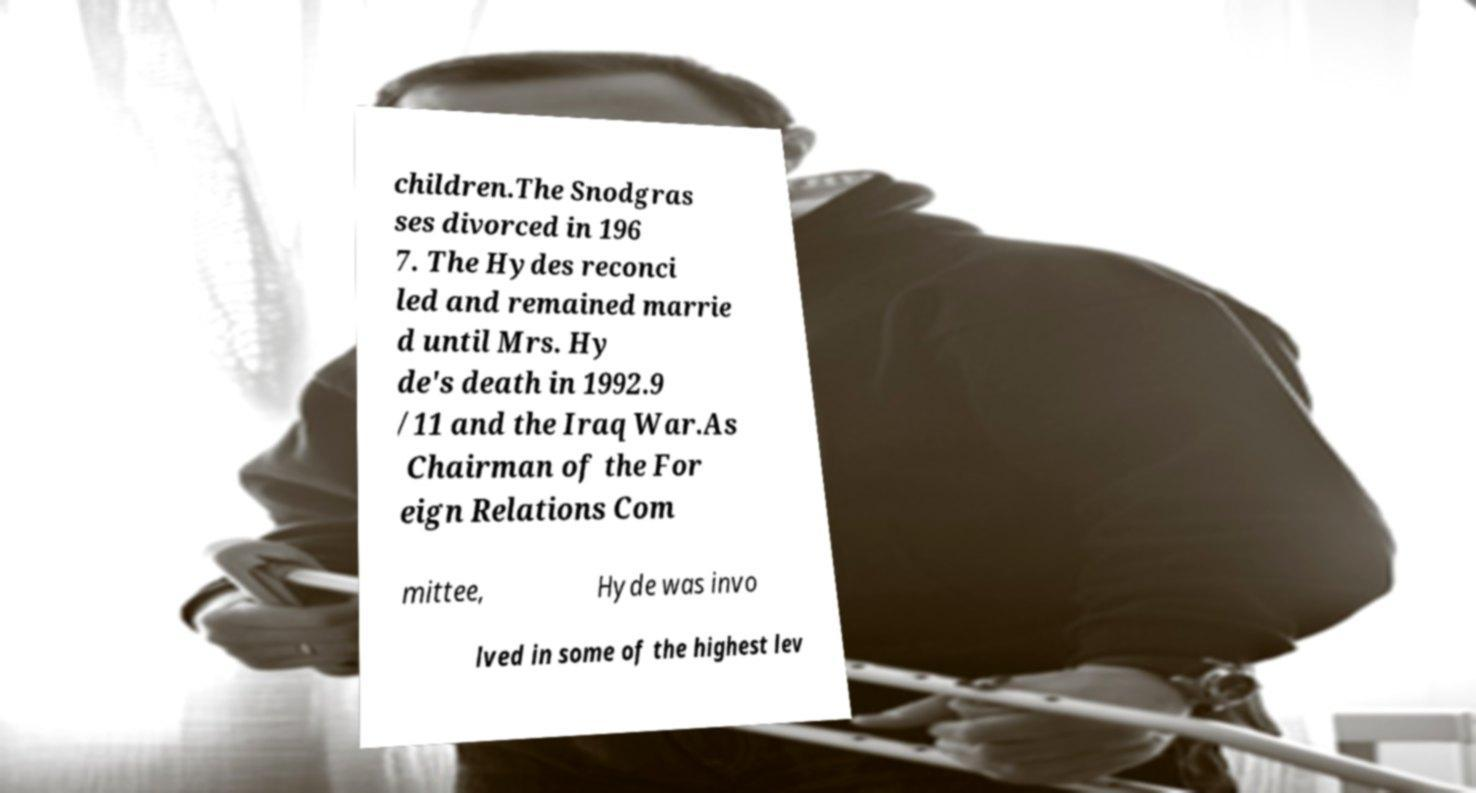For documentation purposes, I need the text within this image transcribed. Could you provide that? children.The Snodgras ses divorced in 196 7. The Hydes reconci led and remained marrie d until Mrs. Hy de's death in 1992.9 /11 and the Iraq War.As Chairman of the For eign Relations Com mittee, Hyde was invo lved in some of the highest lev 